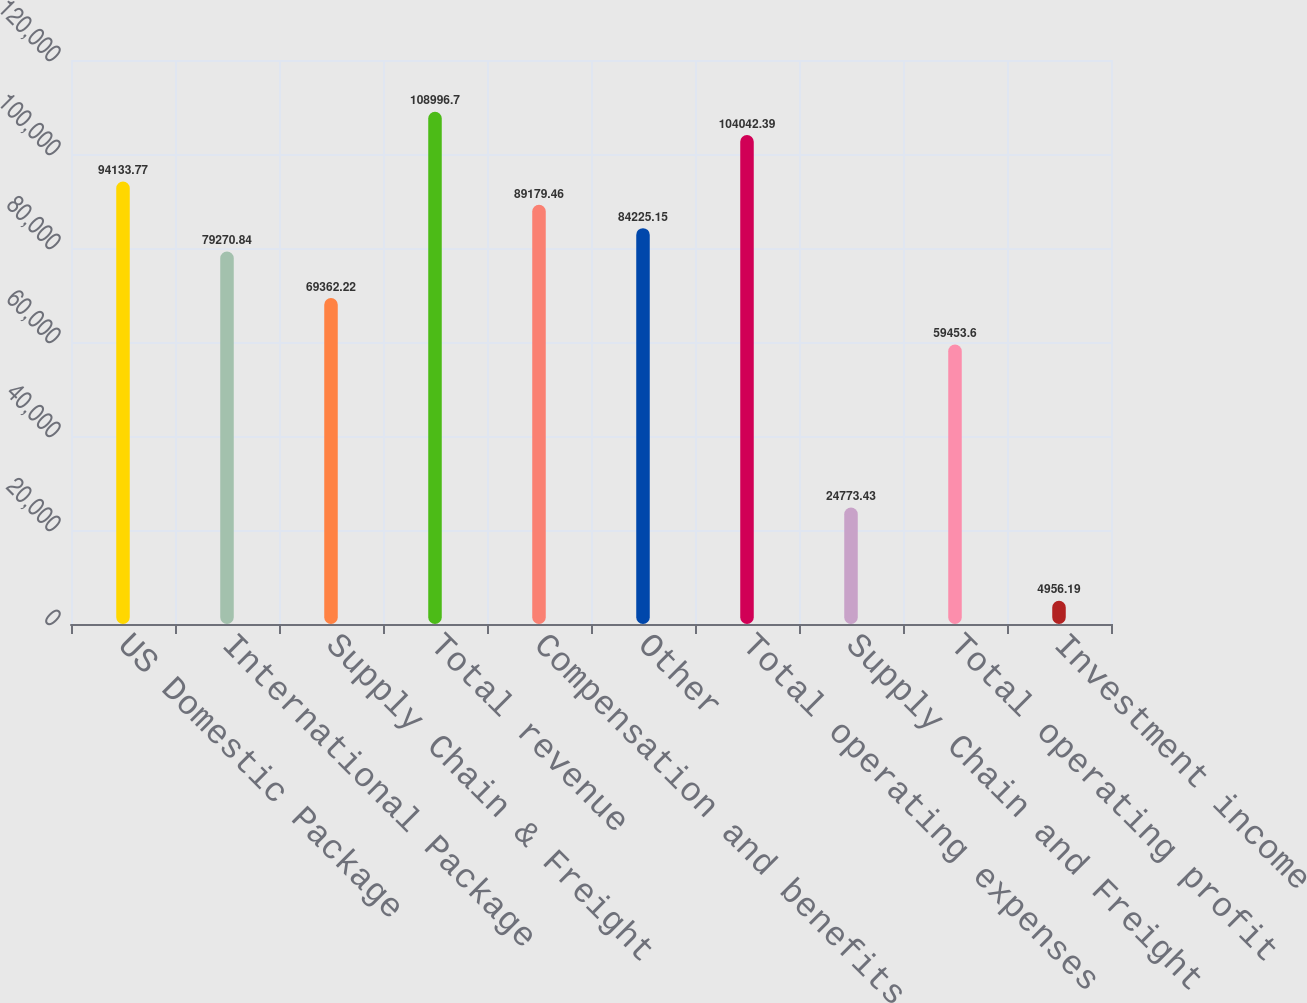Convert chart to OTSL. <chart><loc_0><loc_0><loc_500><loc_500><bar_chart><fcel>US Domestic Package<fcel>International Package<fcel>Supply Chain & Freight<fcel>Total revenue<fcel>Compensation and benefits<fcel>Other<fcel>Total operating expenses<fcel>Supply Chain and Freight<fcel>Total operating profit<fcel>Investment income<nl><fcel>94133.8<fcel>79270.8<fcel>69362.2<fcel>108997<fcel>89179.5<fcel>84225.1<fcel>104042<fcel>24773.4<fcel>59453.6<fcel>4956.19<nl></chart> 